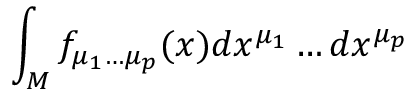<formula> <loc_0><loc_0><loc_500><loc_500>\int _ { M } f _ { \mu _ { 1 } \dots \mu _ { p } } ( x ) d x ^ { \mu _ { 1 } } \dots d x ^ { \mu _ { p } }</formula> 